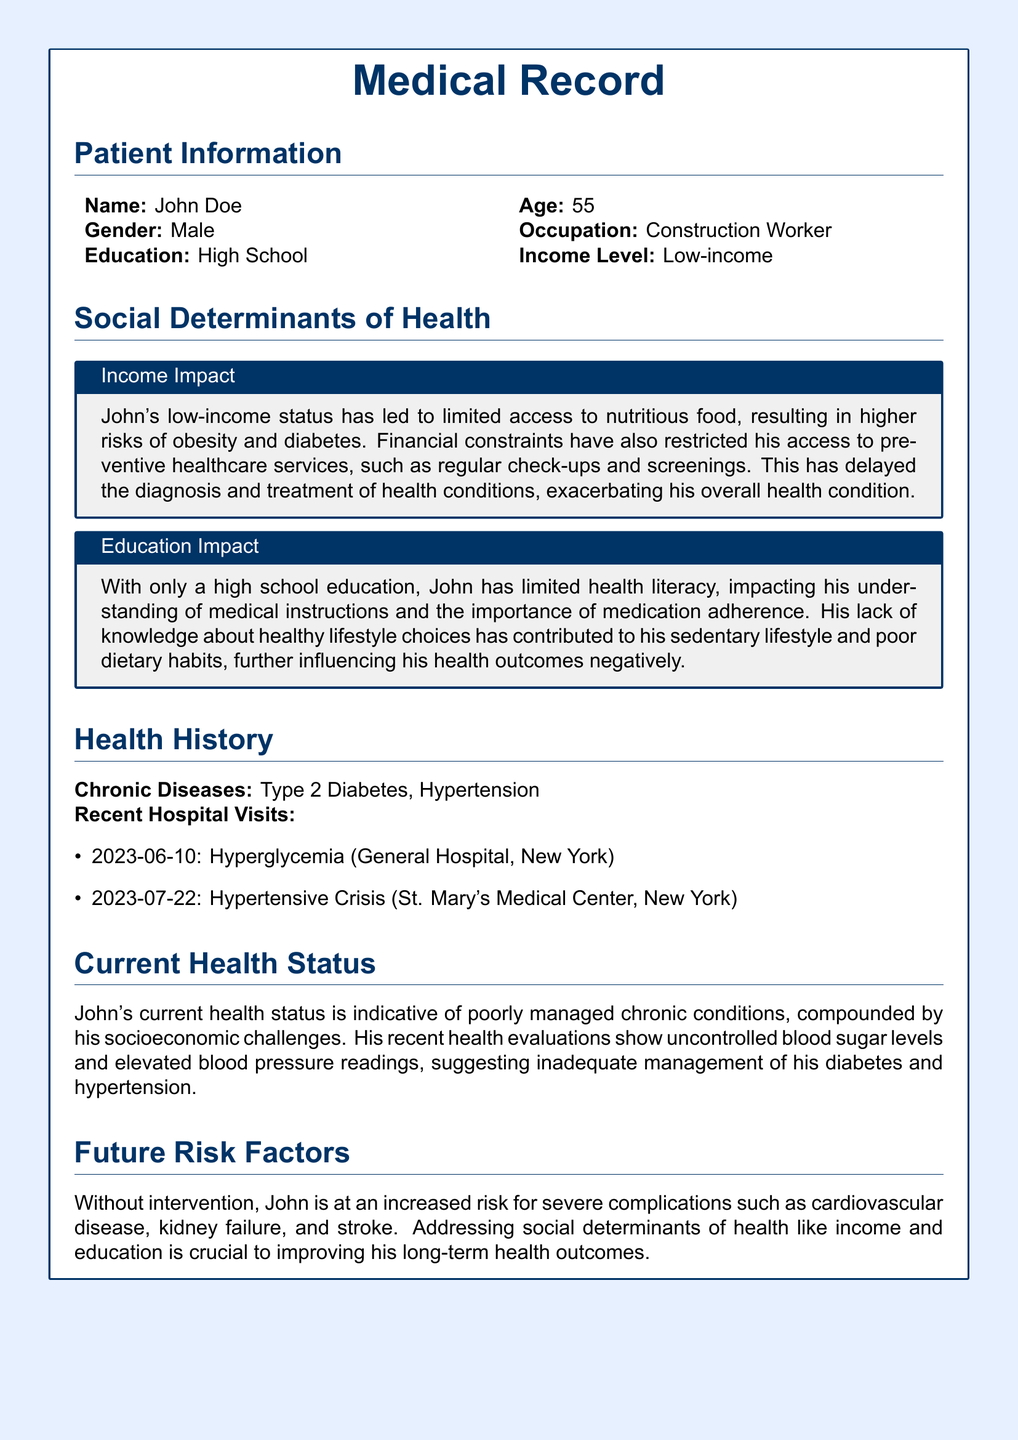What is the patient's name? The patient's name is indicated in the patient information section of the document.
Answer: John Doe What is John's age? John's age is listed directly in the patient information section of the document.
Answer: 55 What is John's income level? John's income level is mentioned in the patient information section, showing his financial status.
Answer: Low-income What chronic diseases does John have? The chronic diseases are explicitly stated in the health history section of the document.
Answer: Type 2 Diabetes, Hypertension What recent hospital visit date indicates a hypertensive crisis? The specific date of the hospital visit for a hypertensive crisis appears in the recent hospital visits section.
Answer: 2023-07-22 How does John's education level impact his health? The document discusses the effects of education on health literacy and lifestyle choices.
Answer: Limited health literacy What are the future risk factors mentioned for John? The future risk factors section outlines potential severe health complications without intervention.
Answer: Cardiovascular disease, kidney failure, stroke What is the main reason for John's limited access to preventive healthcare services? The document states the financial constraints as the reason for limited access.
Answer: Financial constraints Which healthcare facility did John visit for hyperglycemia? The recent hospital visits section provides the details of the healthcare facility for his condition.
Answer: General Hospital, New York 